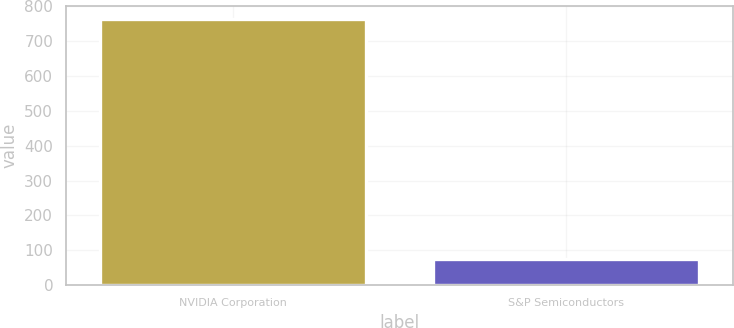Convert chart. <chart><loc_0><loc_0><loc_500><loc_500><bar_chart><fcel>NVIDIA Corporation<fcel>S&P Semiconductors<nl><fcel>762.67<fcel>74.79<nl></chart> 